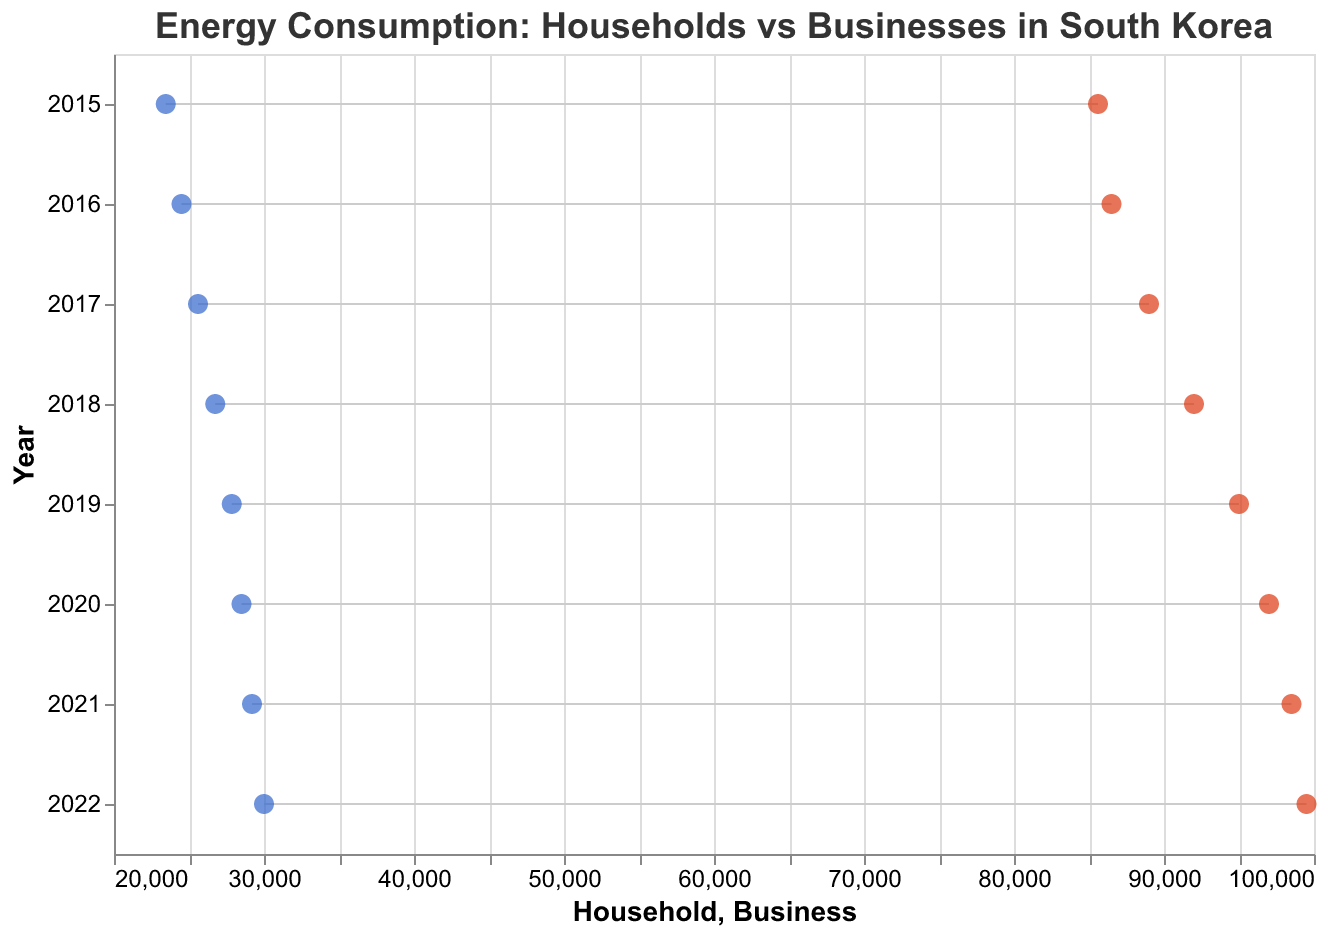What is the title of the figure? The title is usually found at the top of the figure, indicated in larger and bold font for emphasis.
Answer: Energy Consumption: Households vs Businesses in South Korea What is the color of the points representing Household energy consumption? The points representing Household energy consumption are color-coded in the figure with a specific color for clear distinction. In this case, they are colored blue.
Answer: Blue How many years are included in the data presented in the figure? By counting the vertical axis labels, each labeled with a year, we can determine the number of years included.
Answer: 8 What is the Household energy consumption in 2020? Locate the point corresponding to the year 2020 on the vertical axis, and then follow horizontally to the point representing Household energy consumption.
Answer: 28,500 MWh In which year did Business energy consumption reach 99,500 MWh? Follow the horizontal axis representing Business energy consumption and locate the point at 99,500 MWh. Then trace vertically to find the corresponding year.
Answer: 2022 How much did Business energy consumption increase from 2015 to 2022? Subtract the Business energy consumption in 2015 from the consumption in 2022: 99,500 MWh (2022) - 85,600 MWh (2015) = 13,900 MWh.
Answer: 13,900 MWh What is the difference between Household and Business energy consumption in 2017? Find the values for both Household and Business for the year 2017 and subtract to find the difference: 89,000 MWh (Business) - 25,600 MWh (Household) = 63,400 MWh.
Answer: 63,400 MWh Which year saw the smallest difference between Household and Business energy consumption? Calculate the differences for each year and identify the year with the smallest difference. The differences are: 2015 (62,150), 2016 (62,000), 2017 (63,400), 2018 (65,250), 2019 (67,150), 2020 (68,500), 2021 (69,300), 2022 (69,500). The smallest difference is in 2016.
Answer: 2016 How does the trend of Household energy consumption change over the years? Observe the trajectory of the points representing Household energy consumption from 2015 to 2022. The plot shows an increasing trend throughout the years.
Answer: Increasing By how much did Household energy consumption increase each year on average between 2015 and 2022? Sum the yearly increases in Household energy consumption between 2015 and 2022 and then divide by the number of years (7 intervals): ((24,500 - 23,450) + (25,600 - 24,500) + (26,750 - 25,600) + (27,850 - 26,750) + (28,500 - 27,850) + (29,200 - 28,500) + (30,000 - 29,200)) / 7 = 957.14 MWh/year.
Answer: Approximately 957.14 MWh/year 